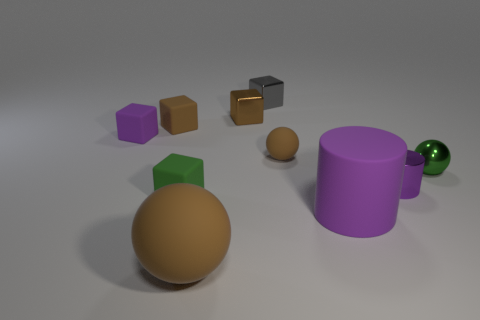Subtract all tiny green matte blocks. How many blocks are left? 4 Subtract all blue spheres. How many brown blocks are left? 2 Subtract all purple blocks. How many blocks are left? 4 Subtract all spheres. How many objects are left? 7 Subtract all green cubes. Subtract all yellow balls. How many cubes are left? 4 Add 2 tiny green matte things. How many tiny green matte things are left? 3 Add 5 small yellow metal cylinders. How many small yellow metal cylinders exist? 5 Subtract 0 cyan spheres. How many objects are left? 10 Subtract all purple metal cylinders. Subtract all green spheres. How many objects are left? 8 